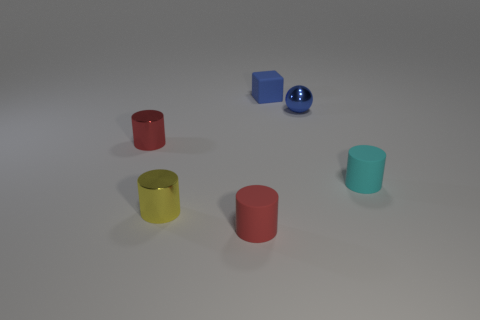What is the color of the rubber cylinder left of the tiny shiny thing that is right of the red cylinder that is to the right of the small yellow metal cylinder?
Ensure brevity in your answer.  Red. Is the color of the small rubber cube the same as the sphere?
Offer a very short reply. Yes. How many tiny things are both in front of the tiny blue sphere and right of the tiny matte block?
Make the answer very short. 1. How many matte objects are big purple objects or cyan cylinders?
Make the answer very short. 1. There is a red cylinder in front of the object on the left side of the tiny yellow shiny thing; what is it made of?
Your answer should be very brief. Rubber. There is a tiny object that is the same color as the block; what shape is it?
Provide a short and direct response. Sphere. What shape is the red metal object that is the same size as the yellow cylinder?
Provide a short and direct response. Cylinder. Is the number of large brown rubber objects less than the number of tiny cylinders?
Your response must be concise. Yes. Are there any small blue spheres on the right side of the tiny cylinder that is behind the tiny cyan rubber thing?
Your answer should be very brief. Yes. What shape is the tiny blue thing that is the same material as the small yellow cylinder?
Offer a very short reply. Sphere. 